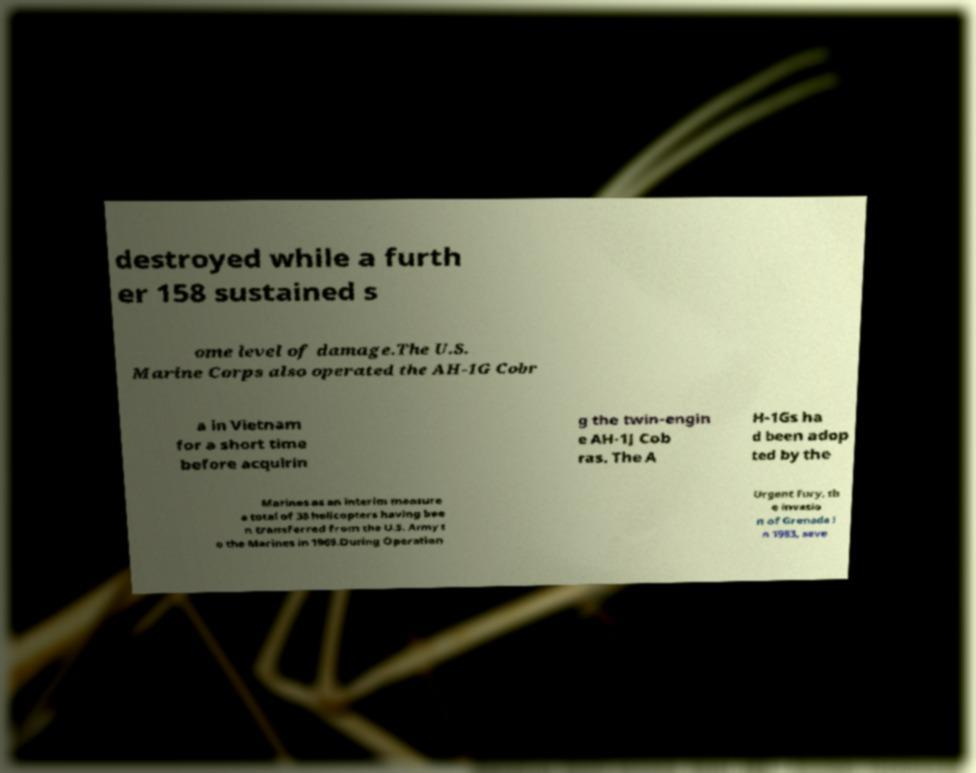I need the written content from this picture converted into text. Can you do that? destroyed while a furth er 158 sustained s ome level of damage.The U.S. Marine Corps also operated the AH-1G Cobr a in Vietnam for a short time before acquirin g the twin-engin e AH-1J Cob ras. The A H-1Gs ha d been adop ted by the Marines as an interim measure a total of 38 helicopters having bee n transferred from the U.S. Army t o the Marines in 1969.During Operation Urgent Fury, th e invasio n of Grenada i n 1983, seve 